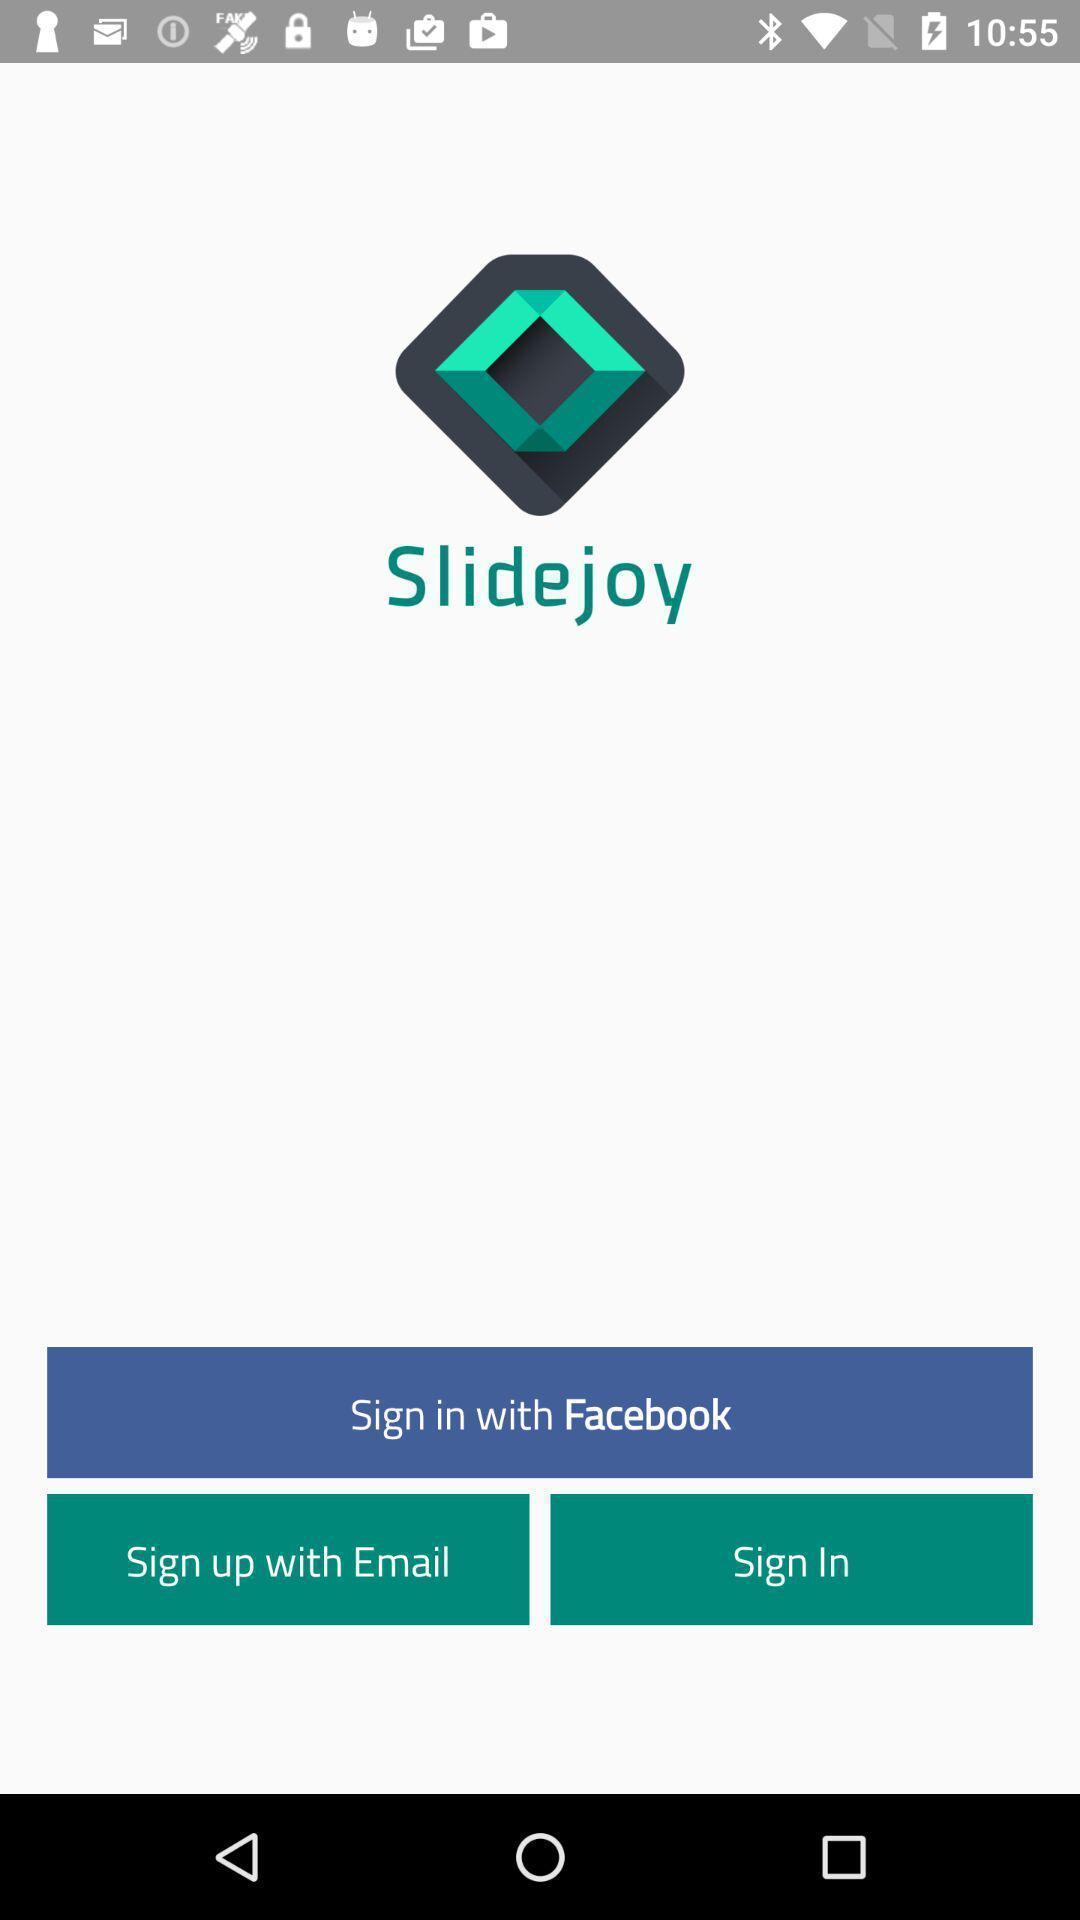Give me a narrative description of this picture. Welcome page. 